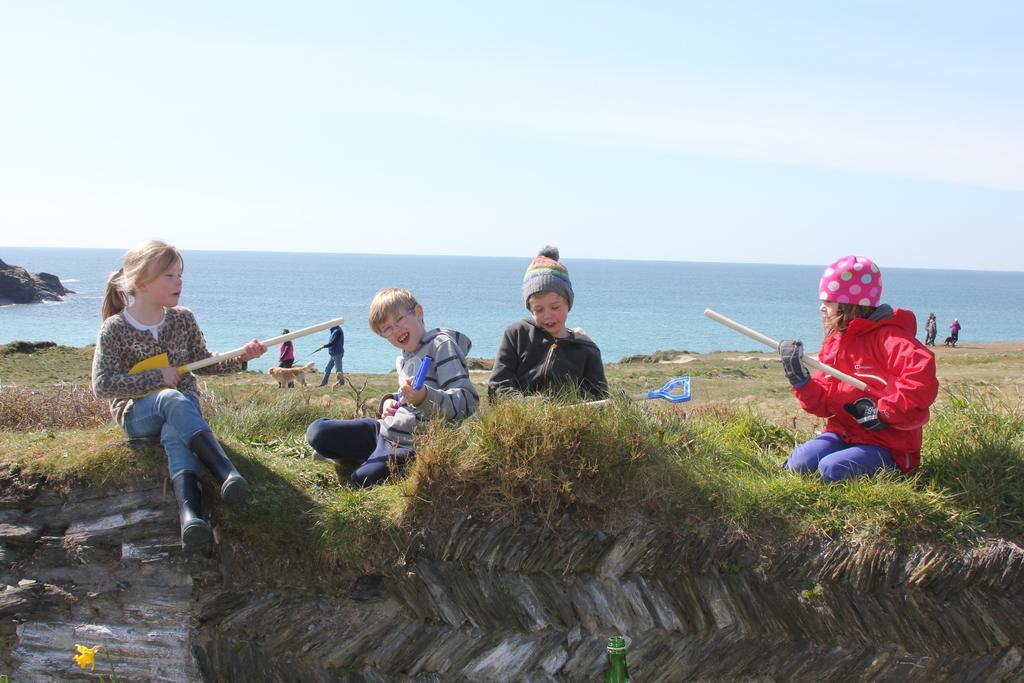Describe this image in one or two sentences. In this image in the center there are persons sitting and playing, there's grass on the ground. In the background there are persons walking and there is an ocean. nnnnnnnnnnnnnnnnnnnnnnn 